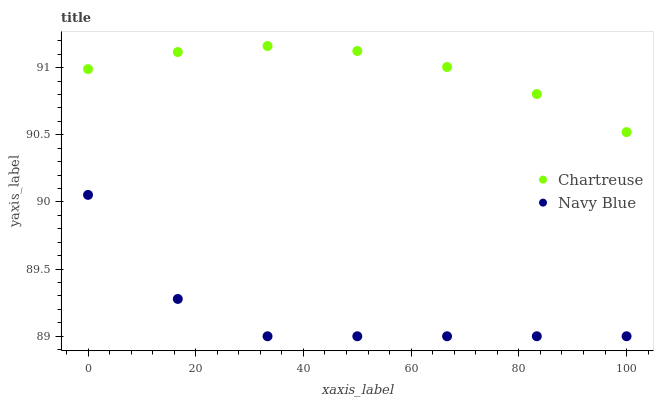Does Navy Blue have the minimum area under the curve?
Answer yes or no. Yes. Does Chartreuse have the maximum area under the curve?
Answer yes or no. Yes. Does Chartreuse have the minimum area under the curve?
Answer yes or no. No. Is Chartreuse the smoothest?
Answer yes or no. Yes. Is Navy Blue the roughest?
Answer yes or no. Yes. Is Chartreuse the roughest?
Answer yes or no. No. Does Navy Blue have the lowest value?
Answer yes or no. Yes. Does Chartreuse have the lowest value?
Answer yes or no. No. Does Chartreuse have the highest value?
Answer yes or no. Yes. Is Navy Blue less than Chartreuse?
Answer yes or no. Yes. Is Chartreuse greater than Navy Blue?
Answer yes or no. Yes. Does Navy Blue intersect Chartreuse?
Answer yes or no. No. 